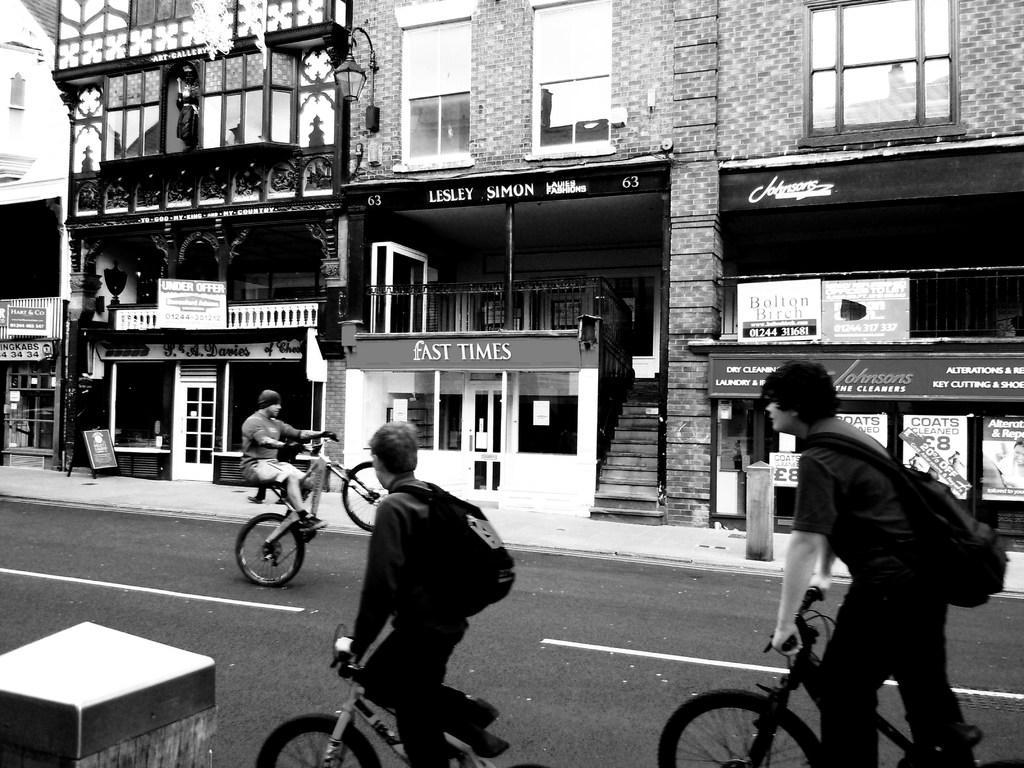Could you give a brief overview of what you see in this image? There are three persons riding bicycles. In the front two persons are wearing bags. And these are on the road. In the background there are buildings, windows, steps, doors, banners and posters. 